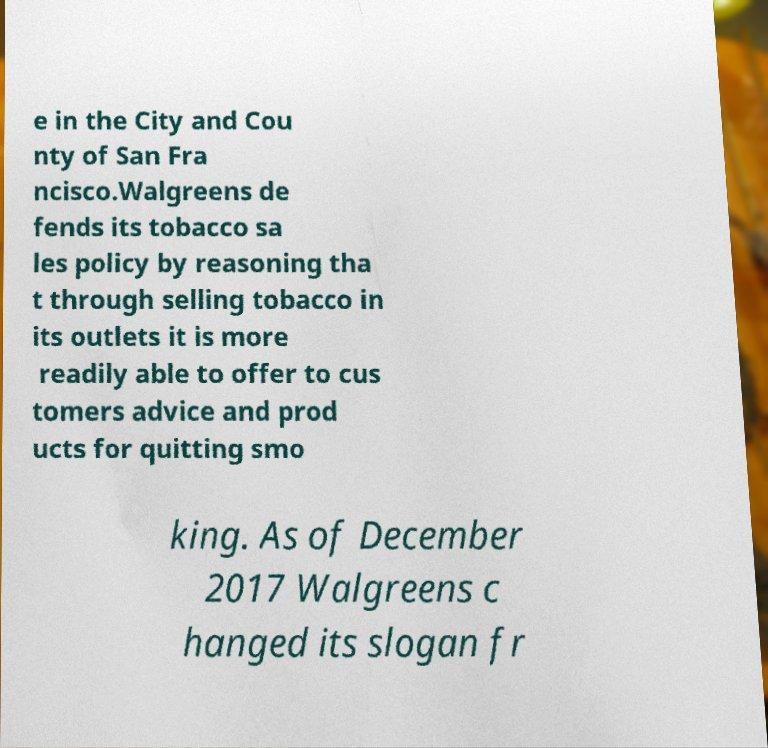For documentation purposes, I need the text within this image transcribed. Could you provide that? e in the City and Cou nty of San Fra ncisco.Walgreens de fends its tobacco sa les policy by reasoning tha t through selling tobacco in its outlets it is more readily able to offer to cus tomers advice and prod ucts for quitting smo king. As of December 2017 Walgreens c hanged its slogan fr 